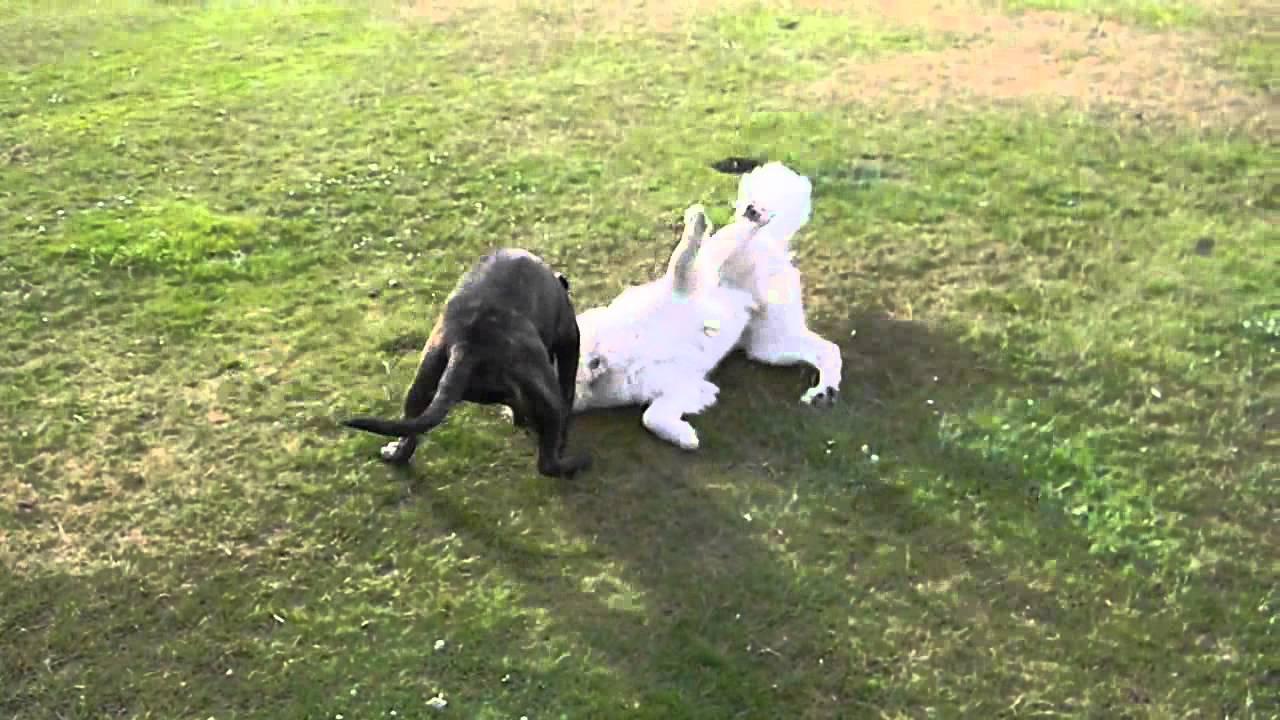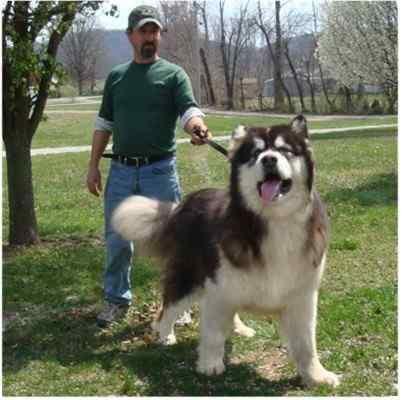The first image is the image on the left, the second image is the image on the right. Considering the images on both sides, is "A man is standing behind a big husky dog, who is standing with his face forward and his tongue hanging." valid? Answer yes or no. Yes. The first image is the image on the left, the second image is the image on the right. Evaluate the accuracy of this statement regarding the images: "The left and right image contains the same number of dogs with one sitting while the other stands with his tongue out.". Is it true? Answer yes or no. No. 